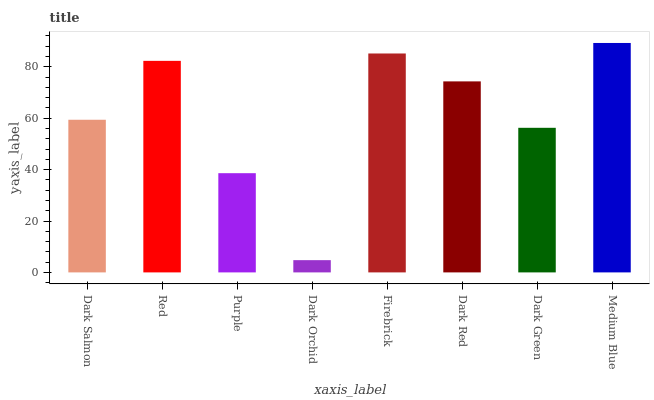Is Dark Orchid the minimum?
Answer yes or no. Yes. Is Medium Blue the maximum?
Answer yes or no. Yes. Is Red the minimum?
Answer yes or no. No. Is Red the maximum?
Answer yes or no. No. Is Red greater than Dark Salmon?
Answer yes or no. Yes. Is Dark Salmon less than Red?
Answer yes or no. Yes. Is Dark Salmon greater than Red?
Answer yes or no. No. Is Red less than Dark Salmon?
Answer yes or no. No. Is Dark Red the high median?
Answer yes or no. Yes. Is Dark Salmon the low median?
Answer yes or no. Yes. Is Firebrick the high median?
Answer yes or no. No. Is Dark Red the low median?
Answer yes or no. No. 